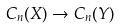<formula> <loc_0><loc_0><loc_500><loc_500>C _ { n } ( X ) \rightarrow C _ { n } ( Y )</formula> 